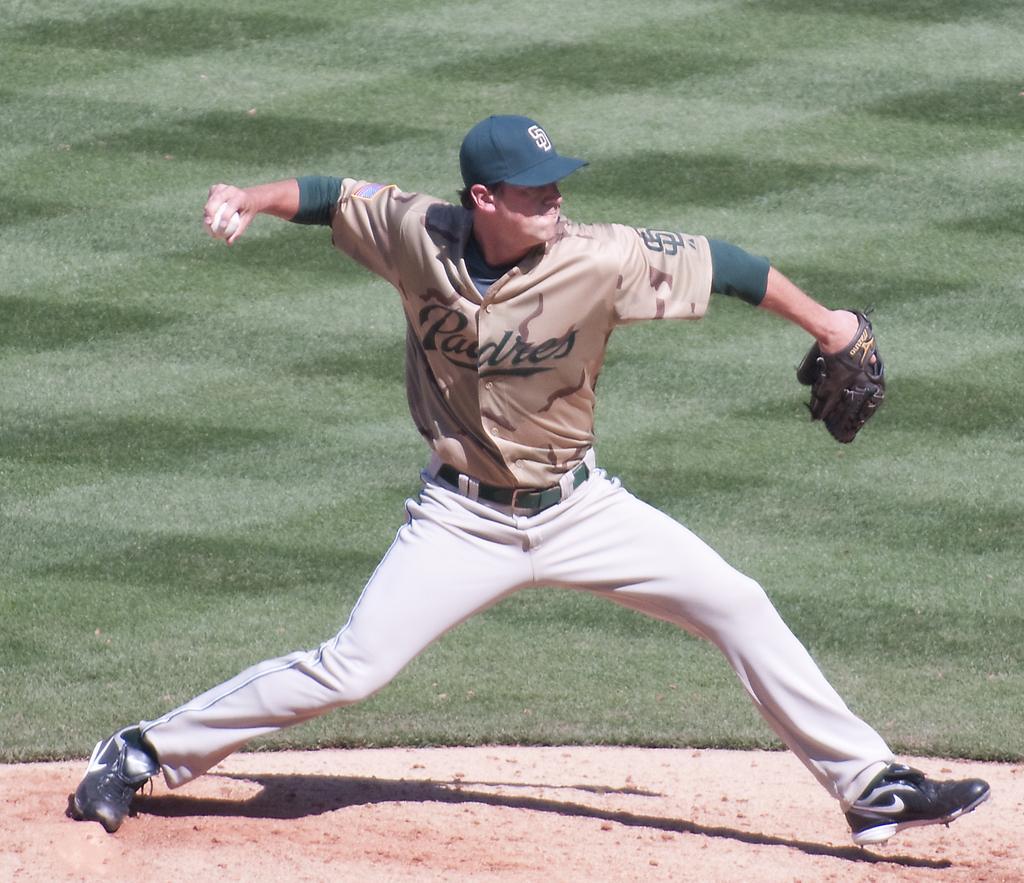Can you describe this image briefly? In this image, we can see a person is wearing gloves and cap. He is trying to throw a ball. He is on the ground. Background we can see the grass. 